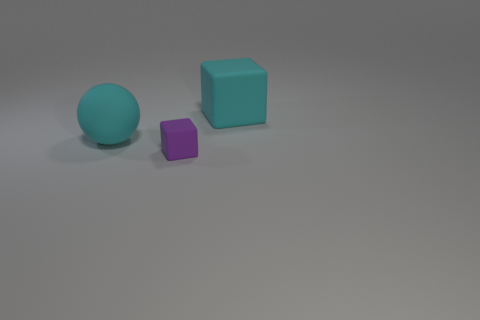What number of objects are rubber spheres that are on the left side of the cyan cube or small purple rubber objects?
Offer a very short reply. 2. What is the shape of the small purple object that is the same material as the big cyan ball?
Provide a succinct answer. Cube. What number of other tiny purple matte things have the same shape as the small thing?
Provide a succinct answer. 0. There is a big matte block; is it the same color as the matte sphere behind the tiny matte thing?
Make the answer very short. Yes. How many cubes are either purple rubber objects or cyan matte things?
Provide a succinct answer. 2. The cube right of the small purple cube is what color?
Make the answer very short. Cyan. There is a thing that is the same color as the big sphere; what is its shape?
Make the answer very short. Cube. How many cyan blocks are the same size as the cyan sphere?
Provide a succinct answer. 1. Is the shape of the large thing that is in front of the large cube the same as the rubber thing on the right side of the tiny matte thing?
Your answer should be compact. No. What is the shape of the matte object that is the same size as the cyan rubber sphere?
Keep it short and to the point. Cube. 